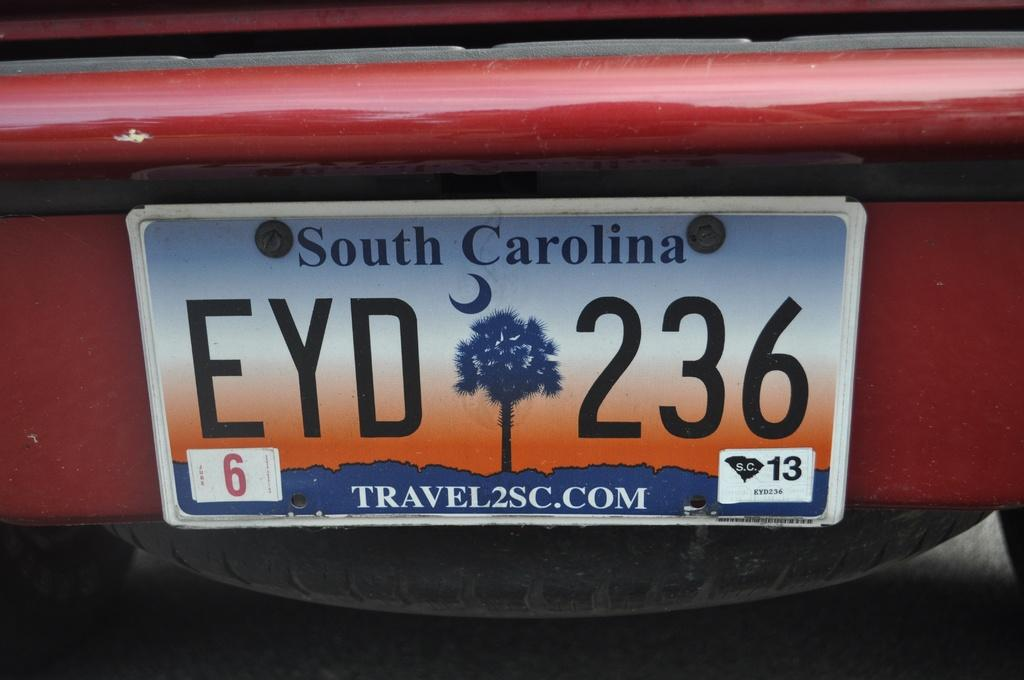<image>
Create a compact narrative representing the image presented. A south carolina license plate EYD 263 on a car. 